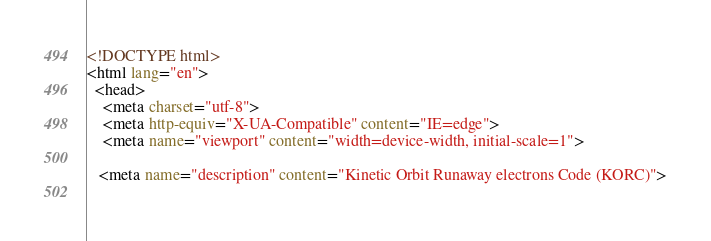Convert code to text. <code><loc_0><loc_0><loc_500><loc_500><_HTML_><!DOCTYPE html>
<html lang="en">
  <head>
    <meta charset="utf-8">
    <meta http-equiv="X-UA-Compatible" content="IE=edge">
    <meta name="viewport" content="width=device-width, initial-scale=1">
   
   <meta name="description" content="Kinetic Orbit Runaway electrons Code (KORC)">
    </code> 